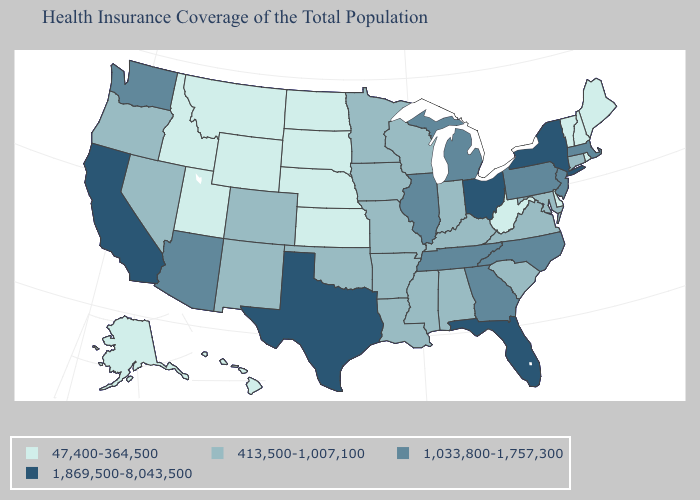Does Ohio have the highest value in the USA?
Short answer required. Yes. Name the states that have a value in the range 1,033,800-1,757,300?
Be succinct. Arizona, Georgia, Illinois, Massachusetts, Michigan, New Jersey, North Carolina, Pennsylvania, Tennessee, Washington. What is the value of Montana?
Quick response, please. 47,400-364,500. Is the legend a continuous bar?
Short answer required. No. Which states have the lowest value in the West?
Keep it brief. Alaska, Hawaii, Idaho, Montana, Utah, Wyoming. Which states have the highest value in the USA?
Concise answer only. California, Florida, New York, Ohio, Texas. What is the value of Maine?
Short answer required. 47,400-364,500. What is the value of South Carolina?
Short answer required. 413,500-1,007,100. Name the states that have a value in the range 1,869,500-8,043,500?
Keep it brief. California, Florida, New York, Ohio, Texas. Does Maryland have the highest value in the USA?
Quick response, please. No. What is the lowest value in the West?
Short answer required. 47,400-364,500. Does the first symbol in the legend represent the smallest category?
Short answer required. Yes. Name the states that have a value in the range 413,500-1,007,100?
Concise answer only. Alabama, Arkansas, Colorado, Connecticut, Indiana, Iowa, Kentucky, Louisiana, Maryland, Minnesota, Mississippi, Missouri, Nevada, New Mexico, Oklahoma, Oregon, South Carolina, Virginia, Wisconsin. What is the value of Massachusetts?
Quick response, please. 1,033,800-1,757,300. 